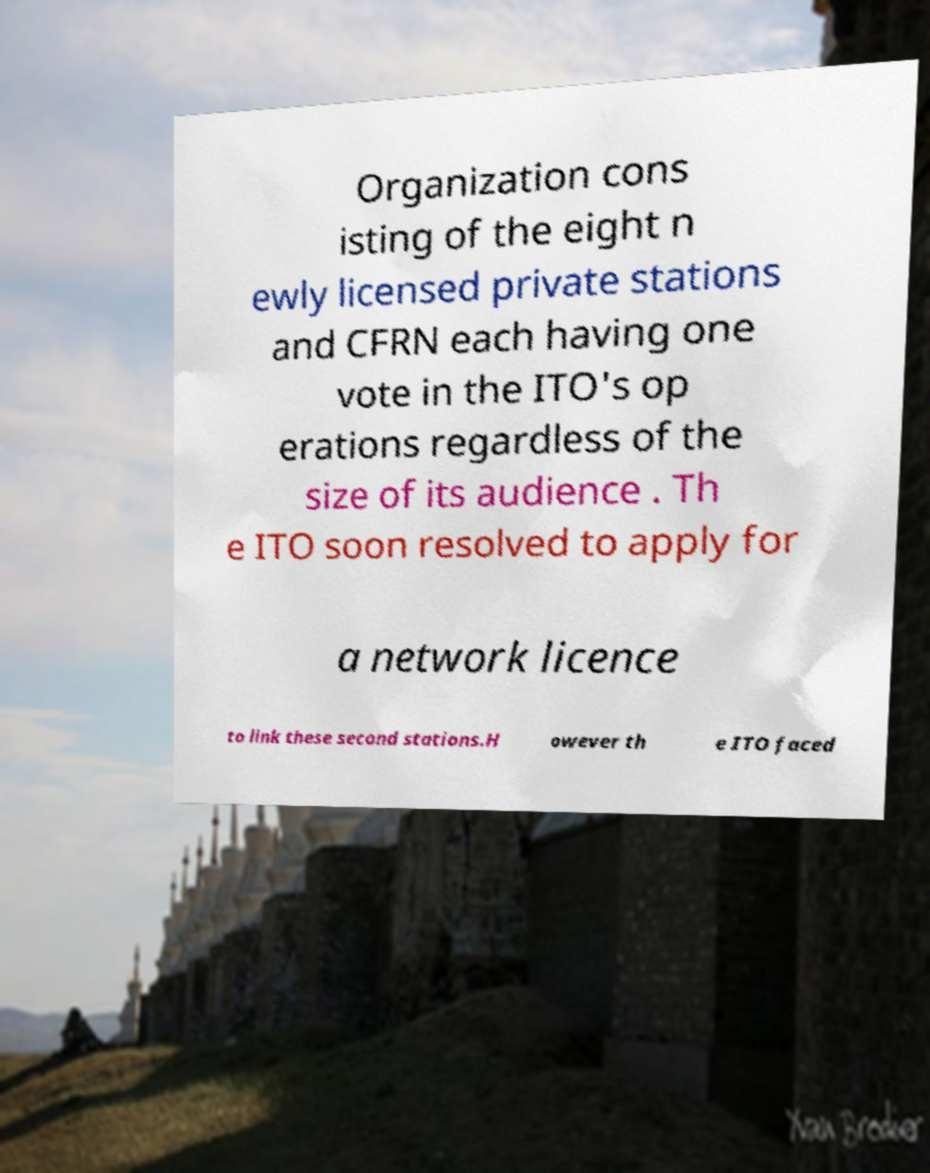There's text embedded in this image that I need extracted. Can you transcribe it verbatim? Organization cons isting of the eight n ewly licensed private stations and CFRN each having one vote in the ITO's op erations regardless of the size of its audience . Th e ITO soon resolved to apply for a network licence to link these second stations.H owever th e ITO faced 